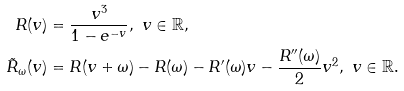Convert formula to latex. <formula><loc_0><loc_0><loc_500><loc_500>R ( v ) & = \frac { v ^ { 3 } } { 1 - e ^ { - v } } , \ v \in { \mathbb { R } } , \\ \tilde { R } _ { \omega } ( v ) & = R ( v + \omega ) - R ( \omega ) - R ^ { \prime } ( \omega ) v - \frac { R ^ { \prime \prime } ( \omega ) } { 2 } v ^ { 2 } , \ v \in { \mathbb { R } } .</formula> 